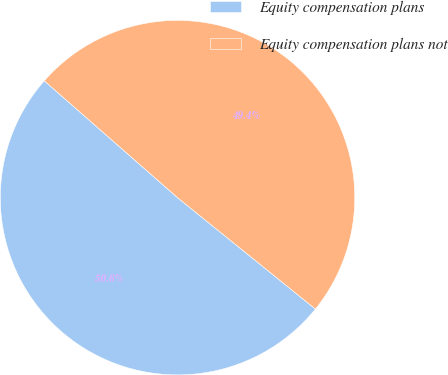<chart> <loc_0><loc_0><loc_500><loc_500><pie_chart><fcel>Equity compensation plans<fcel>Equity compensation plans not<nl><fcel>50.64%<fcel>49.36%<nl></chart> 